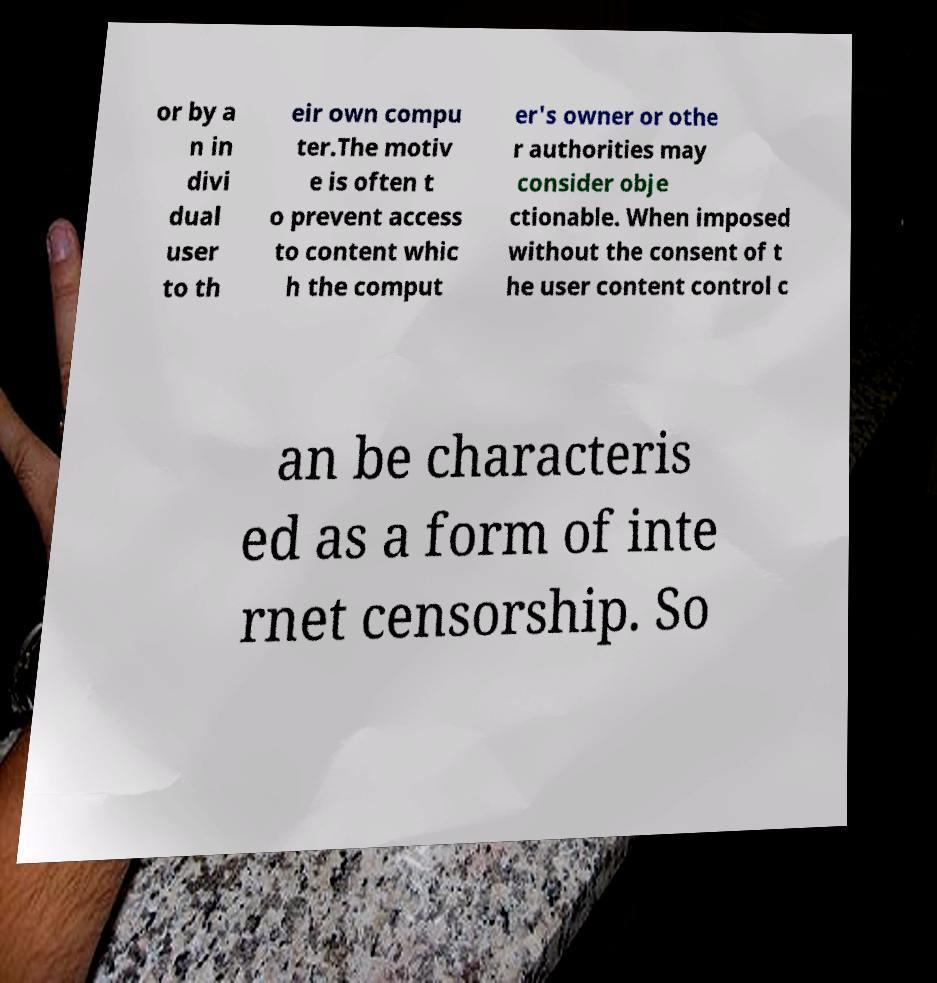Please read and relay the text visible in this image. What does it say? or by a n in divi dual user to th eir own compu ter.The motiv e is often t o prevent access to content whic h the comput er's owner or othe r authorities may consider obje ctionable. When imposed without the consent of t he user content control c an be characteris ed as a form of inte rnet censorship. So 